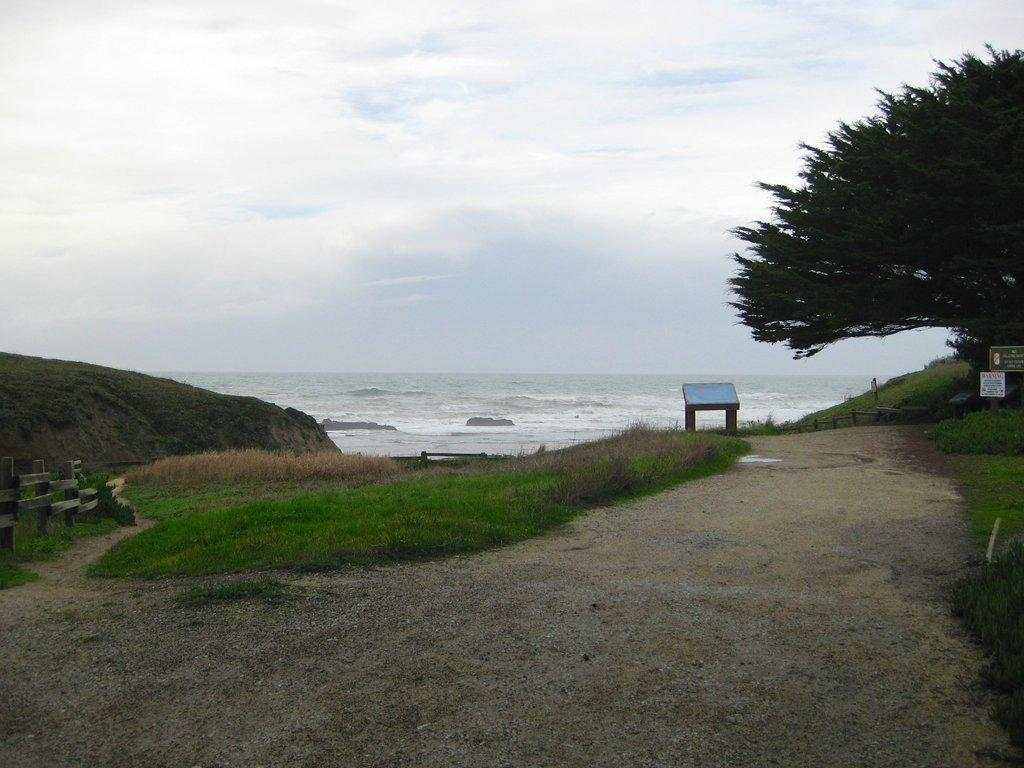What type of vegetation is present in the image? There is a tree and grass on the ground in the image. What natural element can be seen in the image? There is water visible in the image. What type of geological feature is present in the image? There is a rock in the image. How would you describe the sky in the image? The sky is blue and cloudy in the image. What type of signage is present in the image? There are boards with text in the image. What type of bird can be seen flying in the image? There are no birds visible in the image. What type of amusement park can be seen in the background of the image? There is no amusement park present in the image; it features a tree, grass, water, a rock, a blue and cloudy sky, and boards with text. 